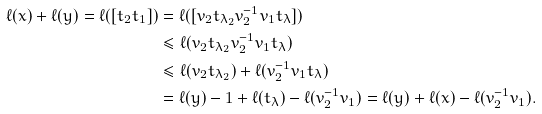Convert formula to latex. <formula><loc_0><loc_0><loc_500><loc_500>\ell ( x ) + \ell ( y ) = \ell ( [ t _ { 2 } t _ { 1 } ] ) & = \ell ( [ v _ { 2 } t _ { \lambda _ { 2 } } v _ { 2 } ^ { - 1 } v _ { 1 } t _ { \lambda } ] ) \\ & \leq \ell ( v _ { 2 } t _ { \lambda _ { 2 } } v _ { 2 } ^ { - 1 } v _ { 1 } t _ { \lambda } ) \\ & \leq \ell ( v _ { 2 } t _ { \lambda _ { 2 } } ) + \ell ( v _ { 2 } ^ { - 1 } v _ { 1 } t _ { \lambda } ) \\ & = \ell ( y ) - 1 + \ell ( t _ { \lambda } ) - \ell ( v _ { 2 } ^ { - 1 } v _ { 1 } ) = \ell ( y ) + \ell ( x ) - \ell ( v _ { 2 } ^ { - 1 } v _ { 1 } ) .</formula> 